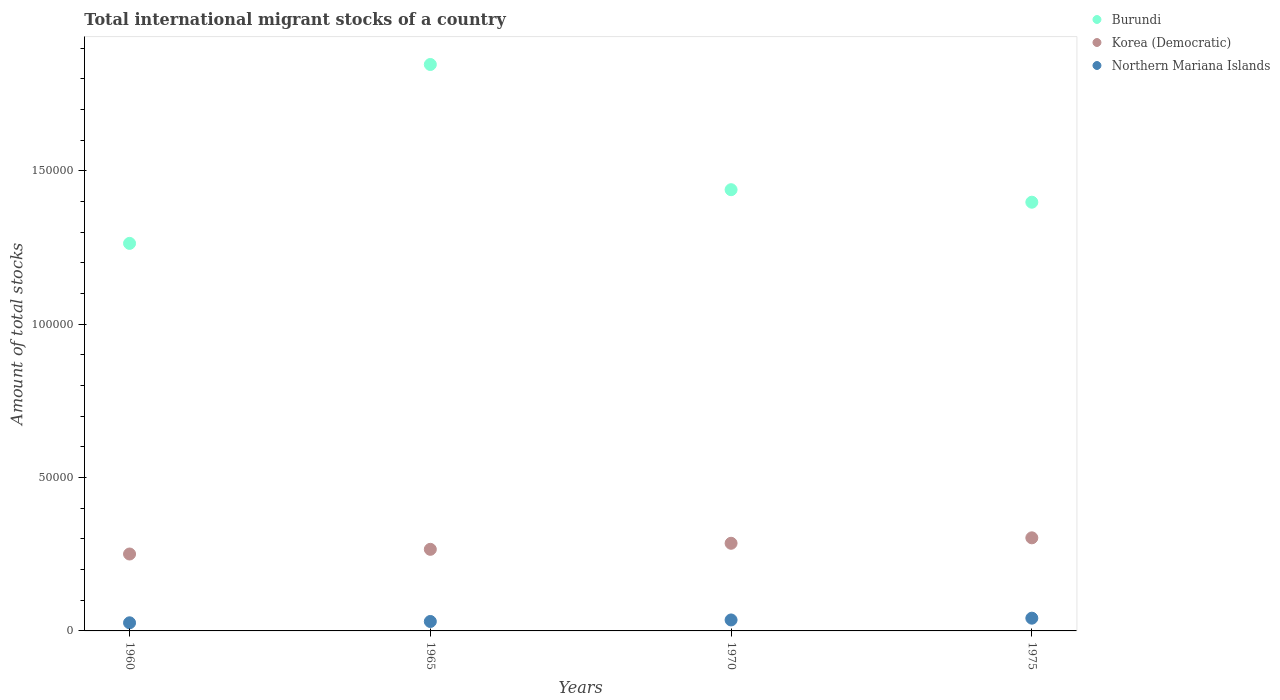Is the number of dotlines equal to the number of legend labels?
Offer a terse response. Yes. What is the amount of total stocks in in Burundi in 1975?
Keep it short and to the point. 1.40e+05. Across all years, what is the maximum amount of total stocks in in Northern Mariana Islands?
Give a very brief answer. 4155. Across all years, what is the minimum amount of total stocks in in Burundi?
Provide a succinct answer. 1.26e+05. In which year was the amount of total stocks in in Burundi maximum?
Your answer should be very brief. 1965. What is the total amount of total stocks in in Burundi in the graph?
Give a very brief answer. 5.95e+05. What is the difference between the amount of total stocks in in Korea (Democratic) in 1965 and that in 1975?
Ensure brevity in your answer.  -3749. What is the difference between the amount of total stocks in in Northern Mariana Islands in 1975 and the amount of total stocks in in Burundi in 1965?
Ensure brevity in your answer.  -1.80e+05. What is the average amount of total stocks in in Burundi per year?
Your answer should be compact. 1.49e+05. In the year 1970, what is the difference between the amount of total stocks in in Burundi and amount of total stocks in in Northern Mariana Islands?
Keep it short and to the point. 1.40e+05. What is the ratio of the amount of total stocks in in Burundi in 1965 to that in 1970?
Give a very brief answer. 1.28. Is the amount of total stocks in in Northern Mariana Islands in 1960 less than that in 1975?
Make the answer very short. Yes. Is the difference between the amount of total stocks in in Burundi in 1960 and 1970 greater than the difference between the amount of total stocks in in Northern Mariana Islands in 1960 and 1970?
Make the answer very short. No. What is the difference between the highest and the second highest amount of total stocks in in Burundi?
Offer a terse response. 4.08e+04. What is the difference between the highest and the lowest amount of total stocks in in Northern Mariana Islands?
Give a very brief answer. 1507. In how many years, is the amount of total stocks in in Northern Mariana Islands greater than the average amount of total stocks in in Northern Mariana Islands taken over all years?
Give a very brief answer. 2. Is it the case that in every year, the sum of the amount of total stocks in in Burundi and amount of total stocks in in Korea (Democratic)  is greater than the amount of total stocks in in Northern Mariana Islands?
Ensure brevity in your answer.  Yes. Does the amount of total stocks in in Northern Mariana Islands monotonically increase over the years?
Your answer should be compact. Yes. Is the amount of total stocks in in Northern Mariana Islands strictly greater than the amount of total stocks in in Burundi over the years?
Make the answer very short. No. How many years are there in the graph?
Your answer should be compact. 4. What is the difference between two consecutive major ticks on the Y-axis?
Provide a succinct answer. 5.00e+04. Does the graph contain grids?
Give a very brief answer. No. What is the title of the graph?
Your answer should be very brief. Total international migrant stocks of a country. What is the label or title of the X-axis?
Provide a succinct answer. Years. What is the label or title of the Y-axis?
Provide a short and direct response. Amount of total stocks. What is the Amount of total stocks of Burundi in 1960?
Your answer should be very brief. 1.26e+05. What is the Amount of total stocks of Korea (Democratic) in 1960?
Your answer should be compact. 2.51e+04. What is the Amount of total stocks in Northern Mariana Islands in 1960?
Provide a short and direct response. 2648. What is the Amount of total stocks in Burundi in 1965?
Your answer should be very brief. 1.85e+05. What is the Amount of total stocks of Korea (Democratic) in 1965?
Your answer should be compact. 2.66e+04. What is the Amount of total stocks in Northern Mariana Islands in 1965?
Provide a short and direct response. 3077. What is the Amount of total stocks in Burundi in 1970?
Your response must be concise. 1.44e+05. What is the Amount of total stocks in Korea (Democratic) in 1970?
Offer a very short reply. 2.86e+04. What is the Amount of total stocks in Northern Mariana Islands in 1970?
Your answer should be compact. 3576. What is the Amount of total stocks in Burundi in 1975?
Keep it short and to the point. 1.40e+05. What is the Amount of total stocks of Korea (Democratic) in 1975?
Give a very brief answer. 3.03e+04. What is the Amount of total stocks of Northern Mariana Islands in 1975?
Your answer should be compact. 4155. Across all years, what is the maximum Amount of total stocks in Burundi?
Your answer should be compact. 1.85e+05. Across all years, what is the maximum Amount of total stocks of Korea (Democratic)?
Offer a terse response. 3.03e+04. Across all years, what is the maximum Amount of total stocks in Northern Mariana Islands?
Offer a terse response. 4155. Across all years, what is the minimum Amount of total stocks in Burundi?
Your response must be concise. 1.26e+05. Across all years, what is the minimum Amount of total stocks of Korea (Democratic)?
Give a very brief answer. 2.51e+04. Across all years, what is the minimum Amount of total stocks of Northern Mariana Islands?
Your response must be concise. 2648. What is the total Amount of total stocks in Burundi in the graph?
Make the answer very short. 5.95e+05. What is the total Amount of total stocks of Korea (Democratic) in the graph?
Your answer should be very brief. 1.11e+05. What is the total Amount of total stocks of Northern Mariana Islands in the graph?
Provide a succinct answer. 1.35e+04. What is the difference between the Amount of total stocks of Burundi in 1960 and that in 1965?
Offer a terse response. -5.83e+04. What is the difference between the Amount of total stocks of Korea (Democratic) in 1960 and that in 1965?
Give a very brief answer. -1524. What is the difference between the Amount of total stocks of Northern Mariana Islands in 1960 and that in 1965?
Ensure brevity in your answer.  -429. What is the difference between the Amount of total stocks of Burundi in 1960 and that in 1970?
Offer a terse response. -1.75e+04. What is the difference between the Amount of total stocks of Korea (Democratic) in 1960 and that in 1970?
Your answer should be compact. -3496. What is the difference between the Amount of total stocks in Northern Mariana Islands in 1960 and that in 1970?
Offer a very short reply. -928. What is the difference between the Amount of total stocks in Burundi in 1960 and that in 1975?
Provide a succinct answer. -1.34e+04. What is the difference between the Amount of total stocks in Korea (Democratic) in 1960 and that in 1975?
Your answer should be very brief. -5273. What is the difference between the Amount of total stocks in Northern Mariana Islands in 1960 and that in 1975?
Offer a terse response. -1507. What is the difference between the Amount of total stocks in Burundi in 1965 and that in 1970?
Offer a terse response. 4.08e+04. What is the difference between the Amount of total stocks in Korea (Democratic) in 1965 and that in 1970?
Offer a very short reply. -1972. What is the difference between the Amount of total stocks of Northern Mariana Islands in 1965 and that in 1970?
Make the answer very short. -499. What is the difference between the Amount of total stocks in Burundi in 1965 and that in 1975?
Your answer should be compact. 4.49e+04. What is the difference between the Amount of total stocks of Korea (Democratic) in 1965 and that in 1975?
Provide a short and direct response. -3749. What is the difference between the Amount of total stocks of Northern Mariana Islands in 1965 and that in 1975?
Offer a very short reply. -1078. What is the difference between the Amount of total stocks of Burundi in 1970 and that in 1975?
Ensure brevity in your answer.  4079. What is the difference between the Amount of total stocks of Korea (Democratic) in 1970 and that in 1975?
Offer a very short reply. -1777. What is the difference between the Amount of total stocks of Northern Mariana Islands in 1970 and that in 1975?
Your answer should be compact. -579. What is the difference between the Amount of total stocks in Burundi in 1960 and the Amount of total stocks in Korea (Democratic) in 1965?
Your answer should be compact. 9.97e+04. What is the difference between the Amount of total stocks of Burundi in 1960 and the Amount of total stocks of Northern Mariana Islands in 1965?
Offer a very short reply. 1.23e+05. What is the difference between the Amount of total stocks in Korea (Democratic) in 1960 and the Amount of total stocks in Northern Mariana Islands in 1965?
Offer a very short reply. 2.20e+04. What is the difference between the Amount of total stocks in Burundi in 1960 and the Amount of total stocks in Korea (Democratic) in 1970?
Offer a very short reply. 9.78e+04. What is the difference between the Amount of total stocks of Burundi in 1960 and the Amount of total stocks of Northern Mariana Islands in 1970?
Your response must be concise. 1.23e+05. What is the difference between the Amount of total stocks of Korea (Democratic) in 1960 and the Amount of total stocks of Northern Mariana Islands in 1970?
Provide a short and direct response. 2.15e+04. What is the difference between the Amount of total stocks in Burundi in 1960 and the Amount of total stocks in Korea (Democratic) in 1975?
Your answer should be very brief. 9.60e+04. What is the difference between the Amount of total stocks in Burundi in 1960 and the Amount of total stocks in Northern Mariana Islands in 1975?
Give a very brief answer. 1.22e+05. What is the difference between the Amount of total stocks in Korea (Democratic) in 1960 and the Amount of total stocks in Northern Mariana Islands in 1975?
Give a very brief answer. 2.09e+04. What is the difference between the Amount of total stocks of Burundi in 1965 and the Amount of total stocks of Korea (Democratic) in 1970?
Offer a very short reply. 1.56e+05. What is the difference between the Amount of total stocks of Burundi in 1965 and the Amount of total stocks of Northern Mariana Islands in 1970?
Keep it short and to the point. 1.81e+05. What is the difference between the Amount of total stocks of Korea (Democratic) in 1965 and the Amount of total stocks of Northern Mariana Islands in 1970?
Your answer should be compact. 2.30e+04. What is the difference between the Amount of total stocks of Burundi in 1965 and the Amount of total stocks of Korea (Democratic) in 1975?
Offer a very short reply. 1.54e+05. What is the difference between the Amount of total stocks of Burundi in 1965 and the Amount of total stocks of Northern Mariana Islands in 1975?
Offer a very short reply. 1.80e+05. What is the difference between the Amount of total stocks in Korea (Democratic) in 1965 and the Amount of total stocks in Northern Mariana Islands in 1975?
Ensure brevity in your answer.  2.24e+04. What is the difference between the Amount of total stocks of Burundi in 1970 and the Amount of total stocks of Korea (Democratic) in 1975?
Provide a short and direct response. 1.13e+05. What is the difference between the Amount of total stocks in Burundi in 1970 and the Amount of total stocks in Northern Mariana Islands in 1975?
Provide a succinct answer. 1.40e+05. What is the difference between the Amount of total stocks in Korea (Democratic) in 1970 and the Amount of total stocks in Northern Mariana Islands in 1975?
Make the answer very short. 2.44e+04. What is the average Amount of total stocks in Burundi per year?
Your answer should be very brief. 1.49e+05. What is the average Amount of total stocks of Korea (Democratic) per year?
Ensure brevity in your answer.  2.76e+04. What is the average Amount of total stocks of Northern Mariana Islands per year?
Offer a terse response. 3364. In the year 1960, what is the difference between the Amount of total stocks in Burundi and Amount of total stocks in Korea (Democratic)?
Offer a terse response. 1.01e+05. In the year 1960, what is the difference between the Amount of total stocks of Burundi and Amount of total stocks of Northern Mariana Islands?
Your answer should be compact. 1.24e+05. In the year 1960, what is the difference between the Amount of total stocks of Korea (Democratic) and Amount of total stocks of Northern Mariana Islands?
Provide a succinct answer. 2.24e+04. In the year 1965, what is the difference between the Amount of total stocks in Burundi and Amount of total stocks in Korea (Democratic)?
Your answer should be very brief. 1.58e+05. In the year 1965, what is the difference between the Amount of total stocks in Burundi and Amount of total stocks in Northern Mariana Islands?
Provide a succinct answer. 1.82e+05. In the year 1965, what is the difference between the Amount of total stocks of Korea (Democratic) and Amount of total stocks of Northern Mariana Islands?
Your answer should be very brief. 2.35e+04. In the year 1970, what is the difference between the Amount of total stocks in Burundi and Amount of total stocks in Korea (Democratic)?
Provide a short and direct response. 1.15e+05. In the year 1970, what is the difference between the Amount of total stocks of Burundi and Amount of total stocks of Northern Mariana Islands?
Keep it short and to the point. 1.40e+05. In the year 1970, what is the difference between the Amount of total stocks in Korea (Democratic) and Amount of total stocks in Northern Mariana Islands?
Give a very brief answer. 2.50e+04. In the year 1975, what is the difference between the Amount of total stocks in Burundi and Amount of total stocks in Korea (Democratic)?
Provide a succinct answer. 1.09e+05. In the year 1975, what is the difference between the Amount of total stocks of Burundi and Amount of total stocks of Northern Mariana Islands?
Provide a short and direct response. 1.36e+05. In the year 1975, what is the difference between the Amount of total stocks in Korea (Democratic) and Amount of total stocks in Northern Mariana Islands?
Your response must be concise. 2.62e+04. What is the ratio of the Amount of total stocks in Burundi in 1960 to that in 1965?
Your answer should be very brief. 0.68. What is the ratio of the Amount of total stocks of Korea (Democratic) in 1960 to that in 1965?
Make the answer very short. 0.94. What is the ratio of the Amount of total stocks in Northern Mariana Islands in 1960 to that in 1965?
Your answer should be compact. 0.86. What is the ratio of the Amount of total stocks in Burundi in 1960 to that in 1970?
Ensure brevity in your answer.  0.88. What is the ratio of the Amount of total stocks in Korea (Democratic) in 1960 to that in 1970?
Provide a succinct answer. 0.88. What is the ratio of the Amount of total stocks in Northern Mariana Islands in 1960 to that in 1970?
Provide a succinct answer. 0.74. What is the ratio of the Amount of total stocks of Burundi in 1960 to that in 1975?
Your response must be concise. 0.9. What is the ratio of the Amount of total stocks in Korea (Democratic) in 1960 to that in 1975?
Offer a very short reply. 0.83. What is the ratio of the Amount of total stocks in Northern Mariana Islands in 1960 to that in 1975?
Your answer should be compact. 0.64. What is the ratio of the Amount of total stocks of Burundi in 1965 to that in 1970?
Make the answer very short. 1.28. What is the ratio of the Amount of total stocks of Korea (Democratic) in 1965 to that in 1970?
Offer a very short reply. 0.93. What is the ratio of the Amount of total stocks of Northern Mariana Islands in 1965 to that in 1970?
Offer a very short reply. 0.86. What is the ratio of the Amount of total stocks of Burundi in 1965 to that in 1975?
Offer a very short reply. 1.32. What is the ratio of the Amount of total stocks in Korea (Democratic) in 1965 to that in 1975?
Provide a succinct answer. 0.88. What is the ratio of the Amount of total stocks of Northern Mariana Islands in 1965 to that in 1975?
Keep it short and to the point. 0.74. What is the ratio of the Amount of total stocks of Burundi in 1970 to that in 1975?
Your answer should be very brief. 1.03. What is the ratio of the Amount of total stocks of Korea (Democratic) in 1970 to that in 1975?
Your answer should be compact. 0.94. What is the ratio of the Amount of total stocks in Northern Mariana Islands in 1970 to that in 1975?
Your answer should be very brief. 0.86. What is the difference between the highest and the second highest Amount of total stocks in Burundi?
Provide a succinct answer. 4.08e+04. What is the difference between the highest and the second highest Amount of total stocks of Korea (Democratic)?
Offer a very short reply. 1777. What is the difference between the highest and the second highest Amount of total stocks of Northern Mariana Islands?
Your response must be concise. 579. What is the difference between the highest and the lowest Amount of total stocks in Burundi?
Provide a short and direct response. 5.83e+04. What is the difference between the highest and the lowest Amount of total stocks of Korea (Democratic)?
Your response must be concise. 5273. What is the difference between the highest and the lowest Amount of total stocks of Northern Mariana Islands?
Provide a short and direct response. 1507. 